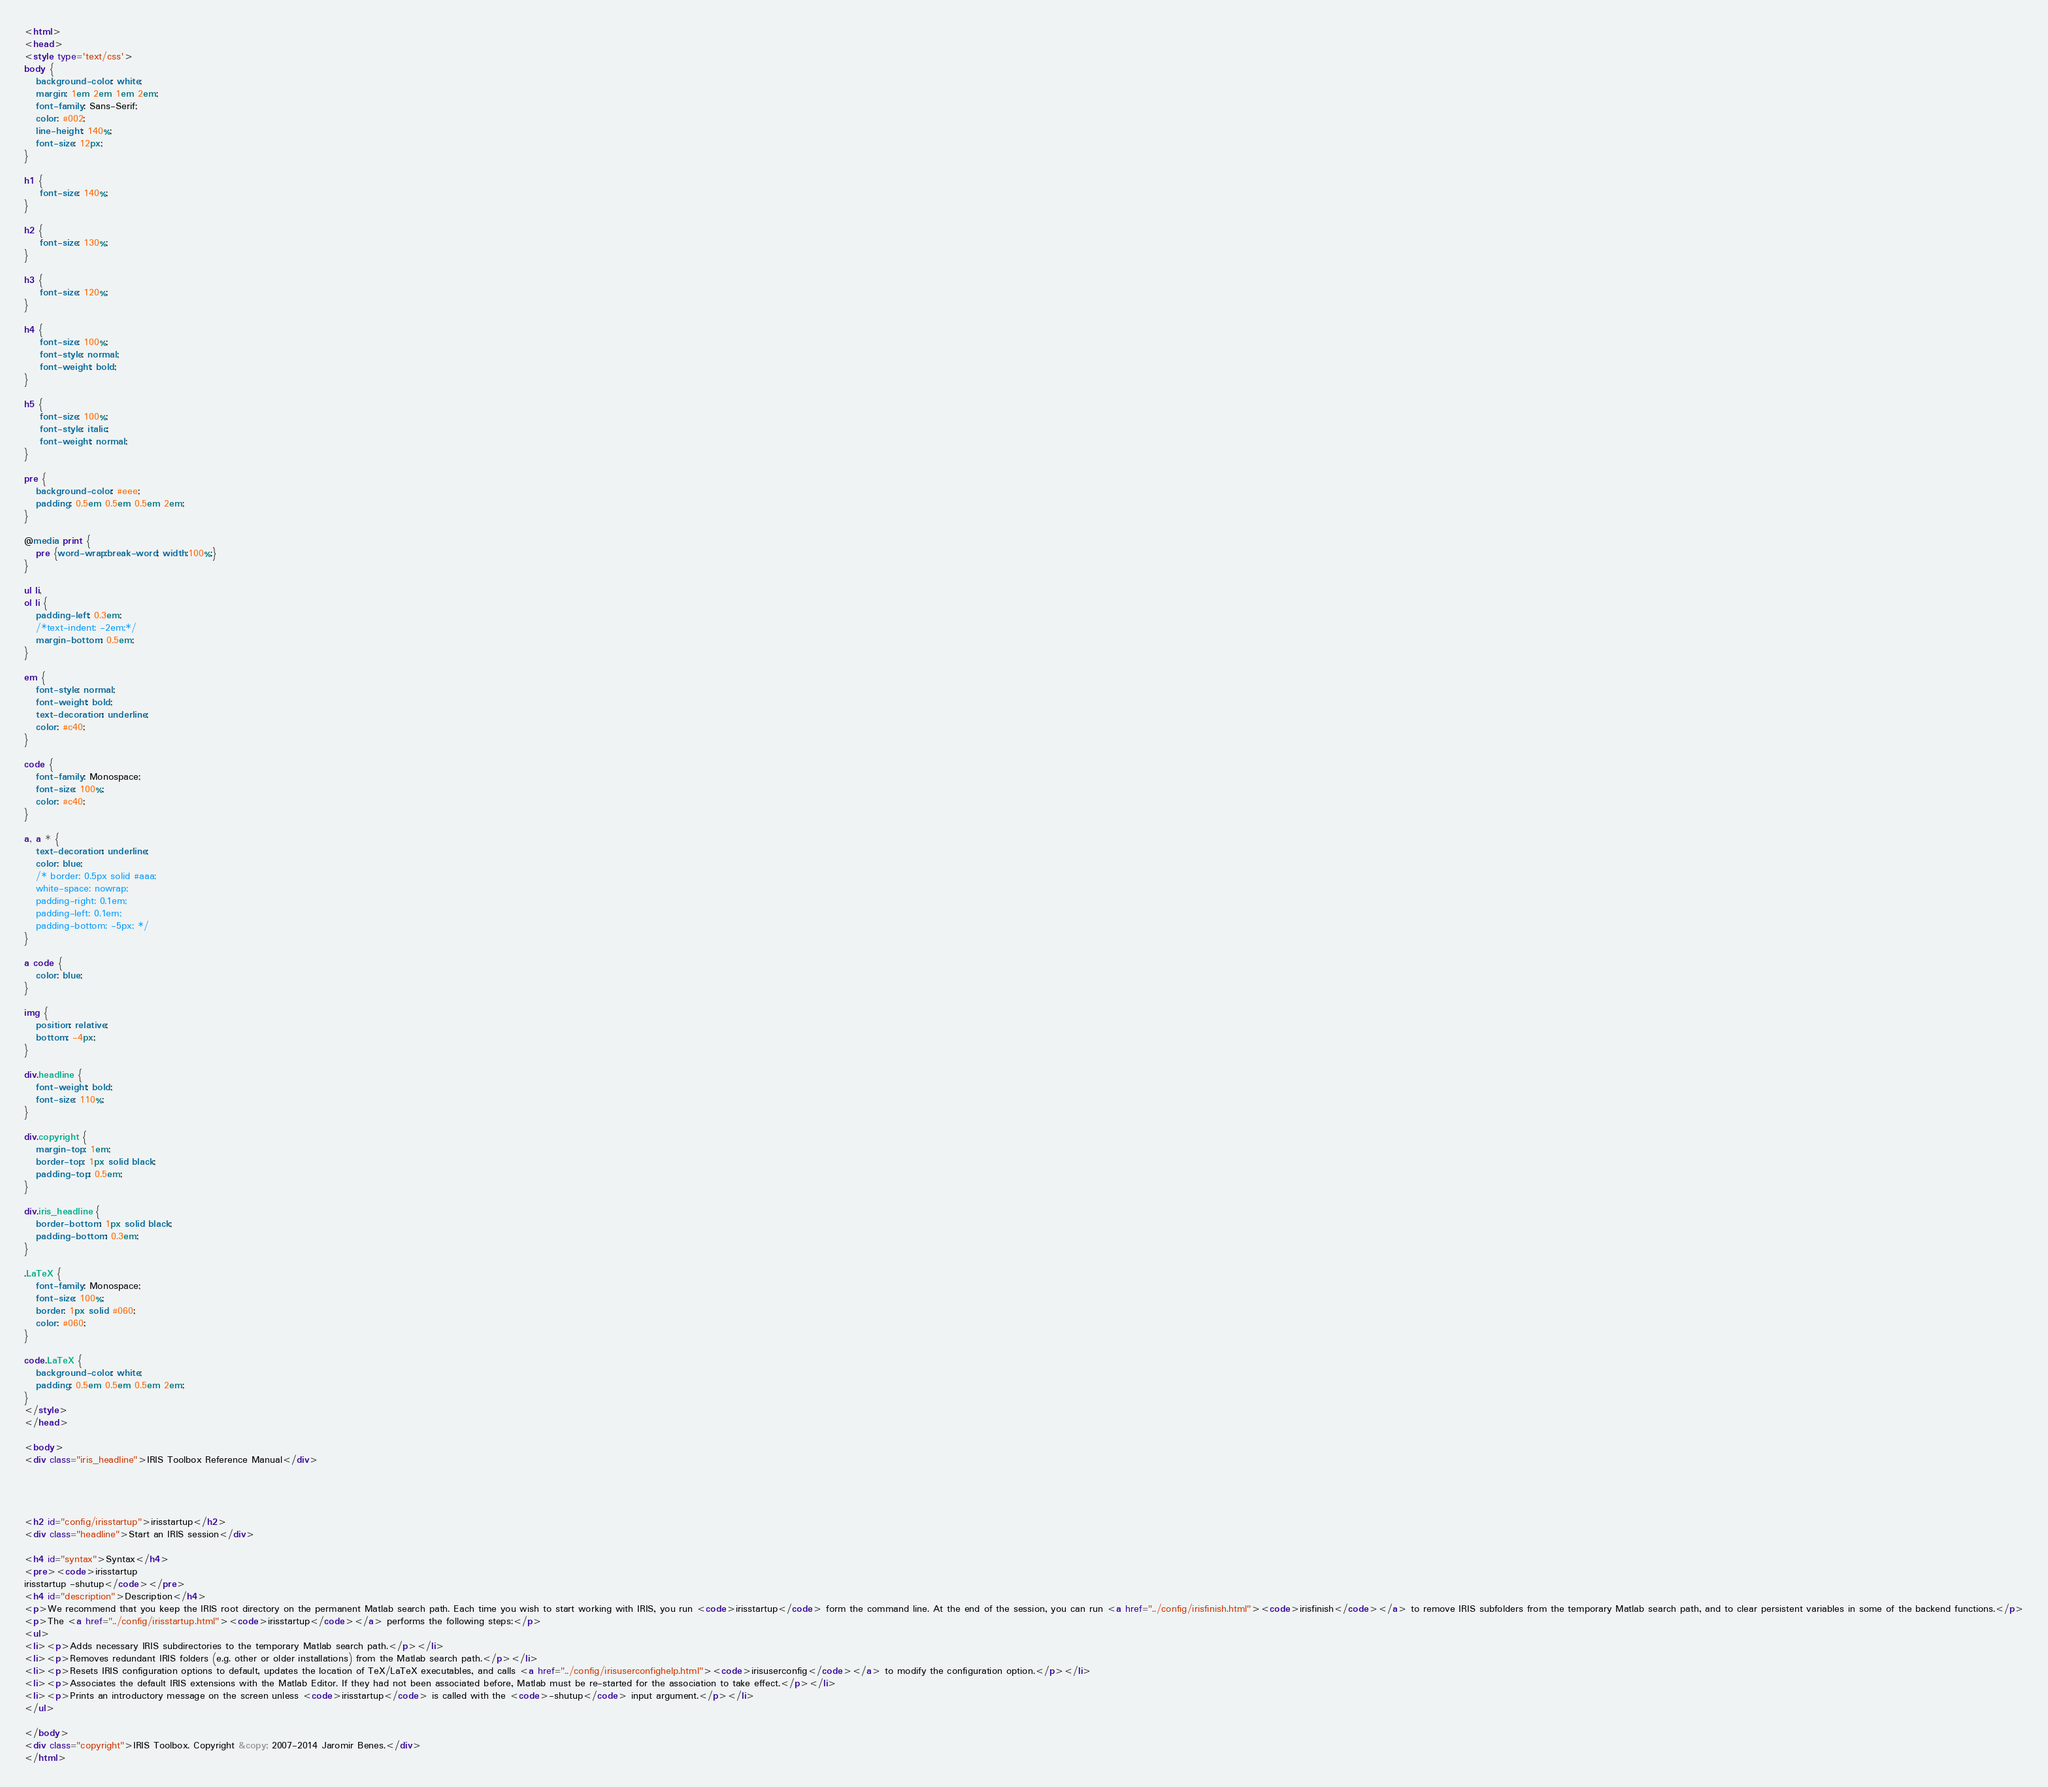Convert code to text. <code><loc_0><loc_0><loc_500><loc_500><_HTML_><html>
<head>
<style type='text/css'>
body {
   background-color: white;
   margin: 1em 2em 1em 2em;
   font-family: Sans-Serif;
   color: #002;
   line-height: 140%;
   font-size: 12px;
}

h1 {
    font-size: 140%;
}

h2 {
    font-size: 130%;
}

h3 {
    font-size: 120%;
}

h4 {
    font-size: 100%;
    font-style: normal;
    font-weight: bold;
}

h5 {
    font-size: 100%;
    font-style: italic;
    font-weight: normal;
}

pre {
   background-color: #eee;
   padding: 0.5em 0.5em 0.5em 2em;
}

@media print {
   pre {word-wrap:break-word; width:100%;}
} 

ul li,
ol li {
   padding-left: 0.3em;
   /*text-indent: -2em;*/
   margin-bottom: 0.5em;
}

em {
   font-style: normal;
   font-weight: bold;
   text-decoration: underline;
   color: #c40;
}

code {
   font-family: Monospace;
   font-size: 100%;
   color: #c40;
}

a, a * {
   text-decoration: underline;
   color: blue;
   /* border: 0.5px solid #aaa;
   white-space: nowrap;
   padding-right: 0.1em;
   padding-left: 0.1em;
   padding-bottom: -5px; */
}

a code {
   color: blue;
}

img {
   position: relative;
   bottom: -4px;
}

div.headline {
   font-weight: bold;
   font-size: 110%;
}

div.copyright {
   margin-top: 1em;
   border-top: 1px solid black;
   padding-top: 0.5em;
}

div.iris_headline {
   border-bottom: 1px solid black;
   padding-bottom: 0.3em;
}

.LaTeX {
   font-family: Monospace;
   font-size: 100%;
   border: 1px solid #060;
   color: #060;
}

code.LaTeX {
   background-color: white;
   padding: 0.5em 0.5em 0.5em 2em;
}
</style>
</head>

<body>
<div class="iris_headline">IRIS Toolbox Reference Manual</div>




<h2 id="config/irisstartup">irisstartup</h2>
<div class="headline">Start an IRIS session</div>

<h4 id="syntax">Syntax</h4>
<pre><code>irisstartup
irisstartup -shutup</code></pre>
<h4 id="description">Description</h4>
<p>We recommend that you keep the IRIS root directory on the permanent Matlab search path. Each time you wish to start working with IRIS, you run <code>irisstartup</code> form the command line. At the end of the session, you can run <a href="../config/irisfinish.html"><code>irisfinish</code></a> to remove IRIS subfolders from the temporary Matlab search path, and to clear persistent variables in some of the backend functions.</p>
<p>The <a href="../config/irisstartup.html"><code>irisstartup</code></a> performs the following steps:</p>
<ul>
<li><p>Adds necessary IRIS subdirectories to the temporary Matlab search path.</p></li>
<li><p>Removes redundant IRIS folders (e.g. other or older installations) from the Matlab search path.</p></li>
<li><p>Resets IRIS configuration options to default, updates the location of TeX/LaTeX executables, and calls <a href="../config/irisuserconfighelp.html"><code>irisuserconfig</code></a> to modify the configuration option.</p></li>
<li><p>Associates the default IRIS extensions with the Matlab Editor. If they had not been associated before, Matlab must be re-started for the association to take effect.</p></li>
<li><p>Prints an introductory message on the screen unless <code>irisstartup</code> is called with the <code>-shutup</code> input argument.</p></li>
</ul>

</body>
<div class="copyright">IRIS Toolbox. Copyright &copy; 2007-2014 Jaromir Benes.</div>
</html>
</code> 